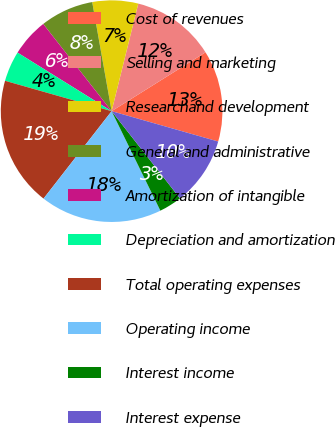<chart> <loc_0><loc_0><loc_500><loc_500><pie_chart><fcel>Cost of revenues<fcel>Selling and marketing<fcel>Researchand development<fcel>General and administrative<fcel>Amortization of intangible<fcel>Depreciation and amortization<fcel>Total operating expenses<fcel>Operating income<fcel>Interest income<fcel>Interest expense<nl><fcel>13.33%<fcel>12.22%<fcel>6.67%<fcel>7.78%<fcel>5.56%<fcel>4.44%<fcel>18.89%<fcel>17.78%<fcel>3.33%<fcel>10.0%<nl></chart> 